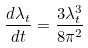<formula> <loc_0><loc_0><loc_500><loc_500>\frac { d \lambda _ { t } } { d t } = \frac { 3 \lambda _ { t } ^ { 3 } } { 8 \pi ^ { 2 } }</formula> 